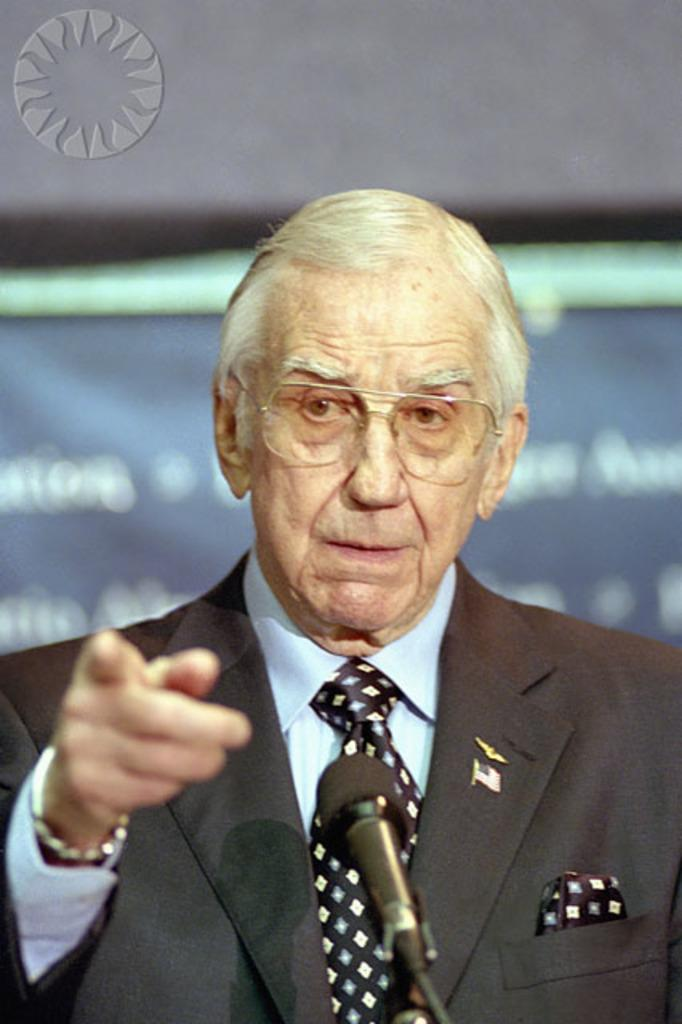Who is present in the image? There is a man in the image. What is the man wearing on his face? The man is wearing glasses (specs) in the image. What accessory is the man wearing on his wrist? The man is wearing a watch in the image. What is the man standing in front of? There is a microphone (mic) on a stand in front of the man in the image. How would you describe the background of the image? The background of the image is blurry. Can you describe any additional details in the image? There is a logo in the left top corner of the image. How much smoke is coming out of the microphone in the image? There is no smoke coming out of the microphone in the image. What causes the microphone to burst in the image? The microphone does not burst in the image; it is a stationary object on a stand. 